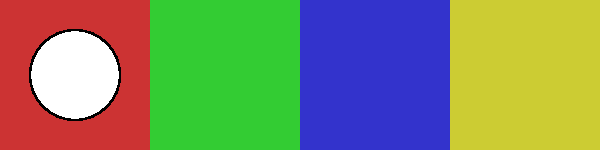In a machine learning model for classifying tribal artifacts based on shape and color, which feature combination would likely be most distinctive for the artifact labeled 'C' in the image? To determine the most distinctive feature combination for artifact 'C', we need to analyze its unique characteristics in terms of both shape and color:

1. Shape analysis:
   - A: Circle
   - B: Square
   - C: Triangle
   - D: Ellipse
   Artifact 'C' is the only triangle, making its shape distinctive.

2. Color analysis:
   - A: Red
   - B: Green
   - C: Blue
   - D: Yellow
   Artifact 'C' is the only blue item, making its color distinctive.

3. Feature importance:
   In machine learning, features that are unique or rare often carry more weight in classification tasks. Both the shape (triangle) and color (blue) of artifact 'C' are unique in this set.

4. Combination power:
   The combination of a unique shape (triangle) and a unique color (blue) creates a powerful feature set for distinguishing artifact 'C' from the others.

5. Machine learning perspective:
   In a classification model, the combination of shape and color would create a clear decision boundary for artifact 'C' in the feature space, likely resulting in high confidence predictions.

Therefore, the combination of triangular shape and blue color would be the most distinctive feature set for classifying artifact 'C' in this machine learning model.
Answer: Triangular shape and blue color 